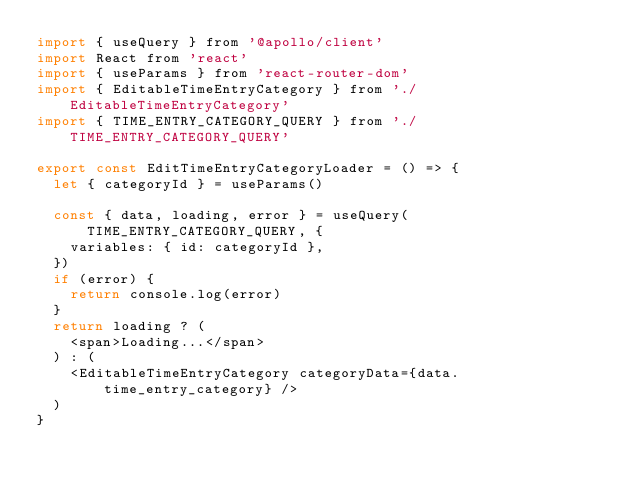<code> <loc_0><loc_0><loc_500><loc_500><_JavaScript_>import { useQuery } from '@apollo/client'
import React from 'react'
import { useParams } from 'react-router-dom'
import { EditableTimeEntryCategory } from './EditableTimeEntryCategory'
import { TIME_ENTRY_CATEGORY_QUERY } from './TIME_ENTRY_CATEGORY_QUERY'

export const EditTimeEntryCategoryLoader = () => {
  let { categoryId } = useParams()

  const { data, loading, error } = useQuery(TIME_ENTRY_CATEGORY_QUERY, {
    variables: { id: categoryId },
  })
  if (error) {
    return console.log(error)
  }
  return loading ? (
    <span>Loading...</span>
  ) : (
    <EditableTimeEntryCategory categoryData={data.time_entry_category} />
  )
}
</code> 